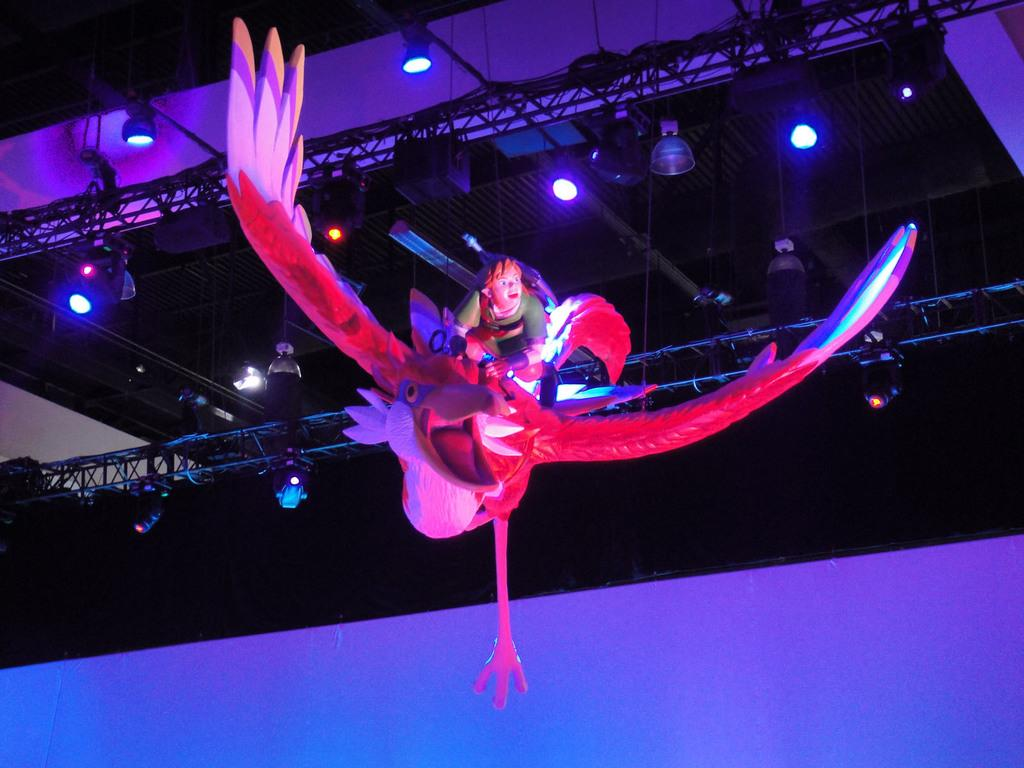What is the main subject of the image? The main subject of the image is an object that looks like a statue. What does the statue represent? The statue represents a person sitting on a bird. What can be seen in the background of the image? There is stage lighting in the background of the image. How are the stage lights positioned? The stage lighting is attached to poles. How many friends can be seen standing next to the statue in the image? There are no friends visible in the image; it only features the statue and stage lighting. What type of throat is visible on the bird in the image? There is no bird with a throat visible in the image; the statue represents a person sitting on a bird. 